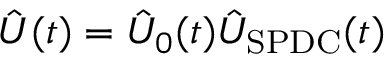Convert formula to latex. <formula><loc_0><loc_0><loc_500><loc_500>\hat { U } ( t ) = \hat { U } _ { 0 } ( t ) \hat { U } _ { S P D C } ( t )</formula> 